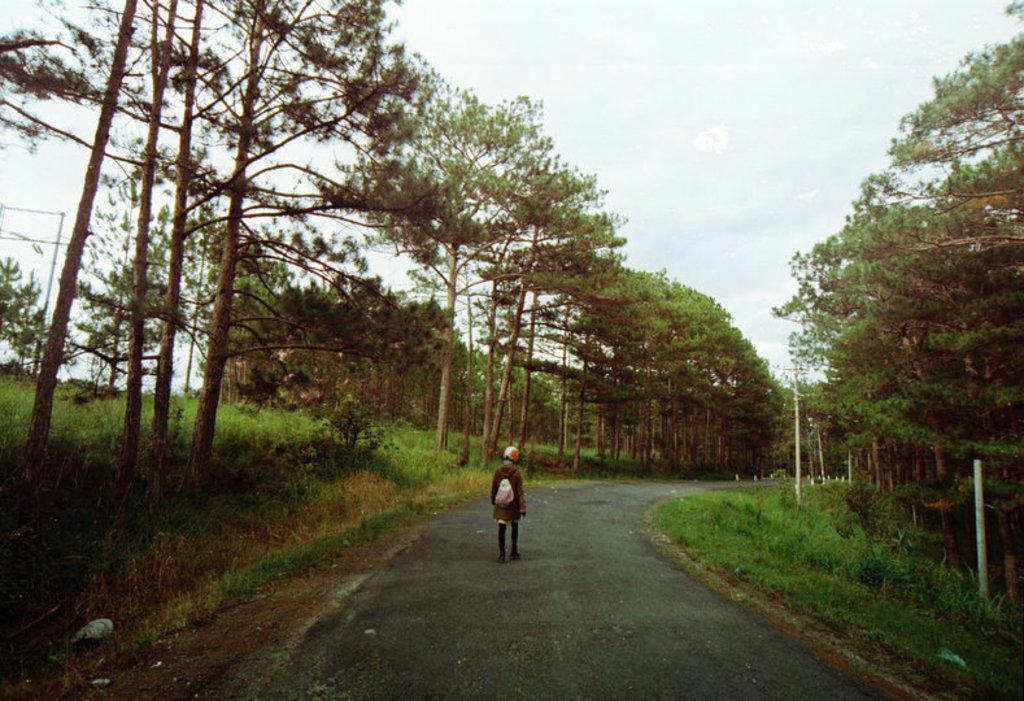Who or what is present in the image? There is a person in the image. What is the person wearing? The person is wearing a bag. What is the person doing in the image? The person is walking on the road. What type of natural elements can be seen in the image? There are trees, plants, grass, and the sky visible in the image. What man-made structures are present in the image? There are poles in the image. What type of crown is the person wearing in the image? There is no crown present in the image; the person is wearing a bag. How does the person guide others in the image? There is no indication in the image that the person is guiding others. 